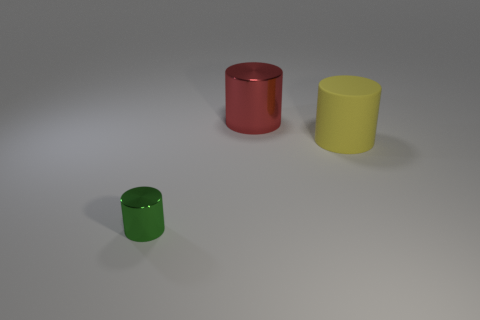How many cylinders are either small rubber things or green metallic things?
Ensure brevity in your answer.  1. There is a metallic cylinder behind the green shiny object; what color is it?
Keep it short and to the point. Red. How many green metal cylinders have the same size as the green thing?
Keep it short and to the point. 0. There is a thing that is to the right of the large red metal thing; does it have the same shape as the object that is in front of the large yellow rubber cylinder?
Keep it short and to the point. Yes. There is a object to the right of the large cylinder that is left of the big cylinder that is in front of the big red cylinder; what is its material?
Offer a very short reply. Rubber. The red metal thing that is the same size as the yellow matte object is what shape?
Provide a short and direct response. Cylinder. Are there any rubber things of the same color as the tiny metallic thing?
Offer a terse response. No. How big is the rubber cylinder?
Your answer should be very brief. Large. Does the tiny cylinder have the same material as the big red thing?
Your response must be concise. Yes. How many big metallic cylinders are behind the large cylinder that is on the right side of the metallic object behind the small thing?
Offer a terse response. 1. 